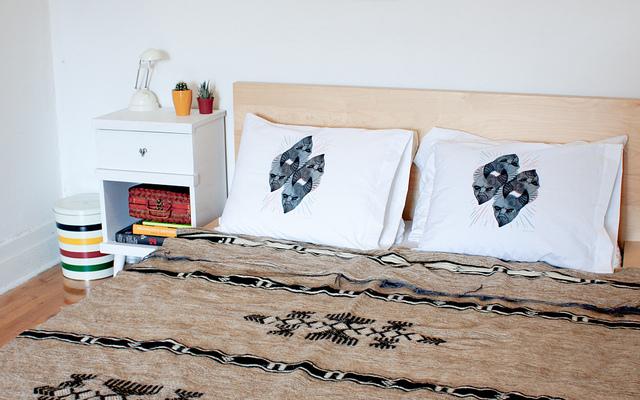What color is the lamp?
Short answer required. White. What is strip and is on the floor?
Keep it brief. Wastebasket. Where is the suitcase?
Give a very brief answer. Nightstand. 